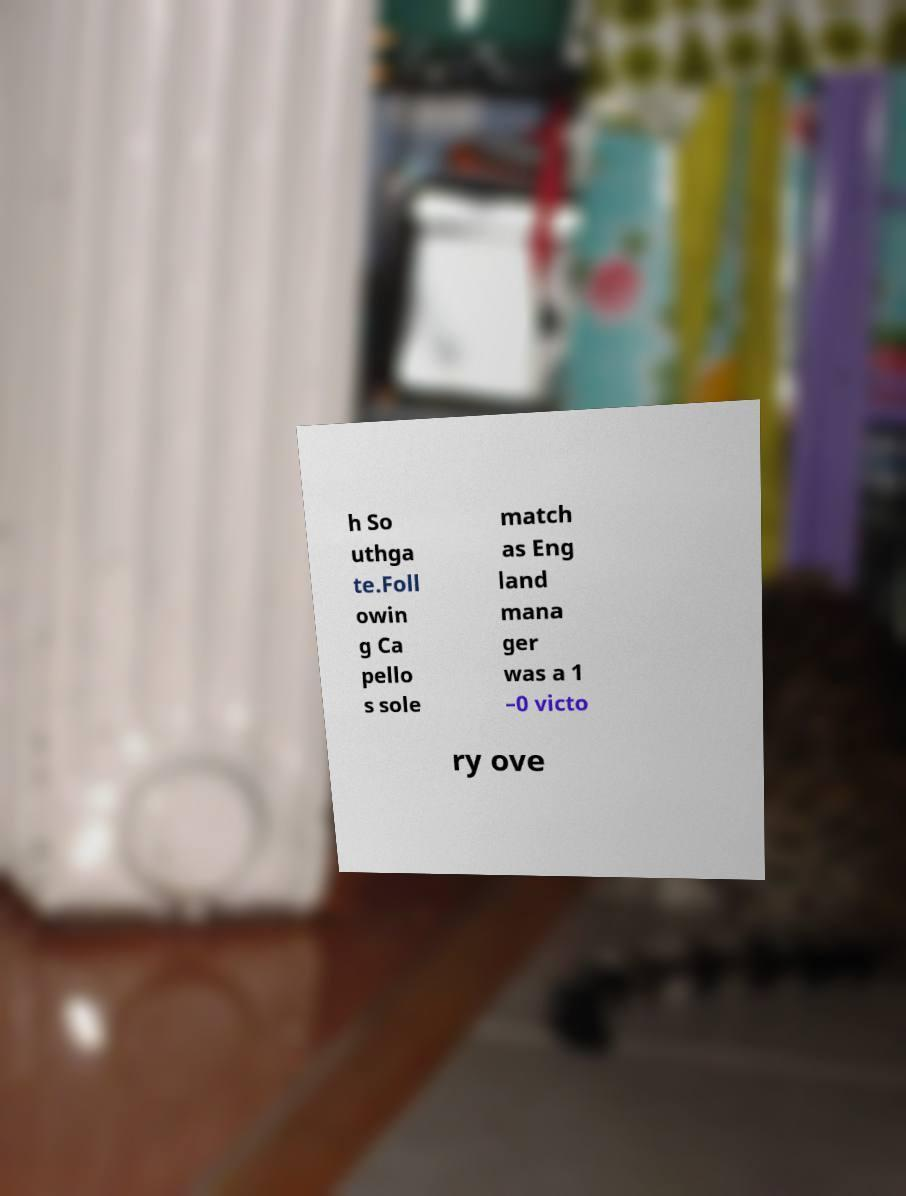Please read and relay the text visible in this image. What does it say? h So uthga te.Foll owin g Ca pello s sole match as Eng land mana ger was a 1 –0 victo ry ove 